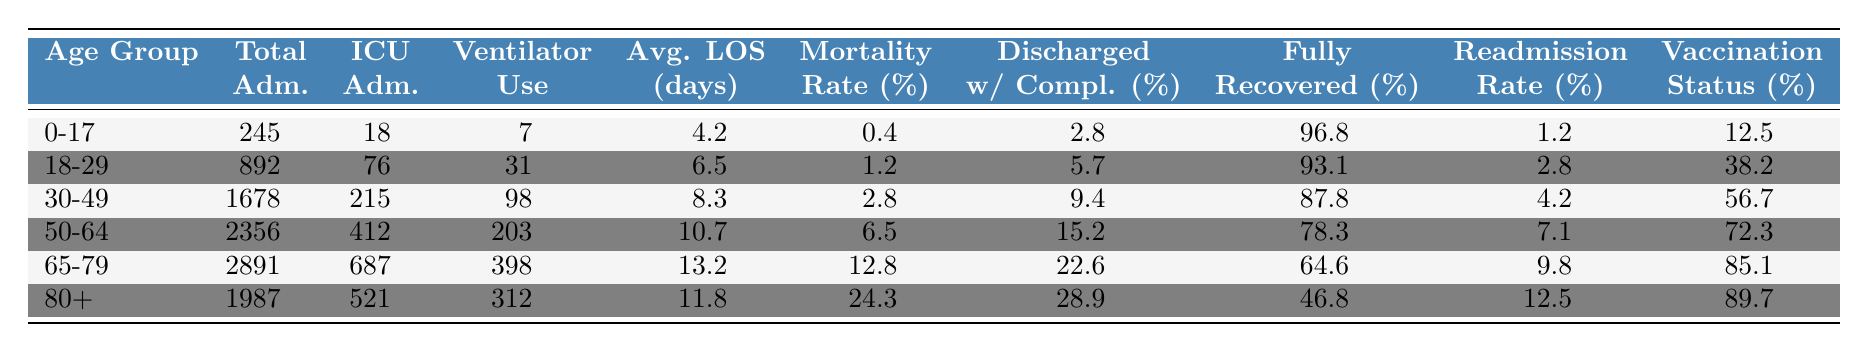What age group has the highest total admissions? Looking at the column labeled "Total Admissions," the age group "50-64" has the highest number with 2356 admissions.
Answer: 50-64 What is the Mortality Rate for patients aged 80 and above? The Mortality Rate for the age group "80+" is listed as 24.3%.
Answer: 24.3% How many patients aged 30-49 were admitted to the ICU? According to the table, the ICU Admissions for the age group "30-49" is 215.
Answer: 215 What is the difference in Average Length of Stay between the age groups 0-17 and 65-79? For "0-17," the Average Length of Stay is 4.2 days, and for "65-79," it is 13.2 days. The difference is 13.2 - 4.2 = 9 days.
Answer: 9 days Is the Readmission Rate for the age group 50-64 higher than that of 18-29? The Readmission Rate for "50-64" is 7.1%, while for "18-29" it is 2.8%. Since 7.1% is greater than 2.8%, the statement is true.
Answer: Yes What percentage of patients aged 65-79 fully recovered? The Fully Recovered percentage for the age group "65-79" is 64.6%.
Answer: 64.6% How does the Ventilator Use for patients aged 50-64 compare to those aged 18-29? The Ventilator Use for "50-64" is 203, and for "18-29" it is 31. Thus, 203 - 31 = 172 more patients aged 50-64 required ventilators.
Answer: 172 more What is the average vaccination status for patients across all age groups? To find the average Vaccination Status, add: (12.5 + 38.2 + 56.7 + 72.3 + 85.1 + 89.7) = 354.5, and divide by 6 (the number of age groups), which is 354.5 / 6 = 59.1%.
Answer: 59.1% Which age group has the lowest percentage of patients fully recovered? The age group "80+" has the lowest Fully Recovered percentage at 46.8%.
Answer: 80+ Is the mortality rate for the age group 30-49 lower than that of 18-29? The Mortality Rate for "30-49" is 2.8%, while for "18-29" it is 1.2%. Therefore, 2.8% is higher than 1.2%, making the statement false.
Answer: No 